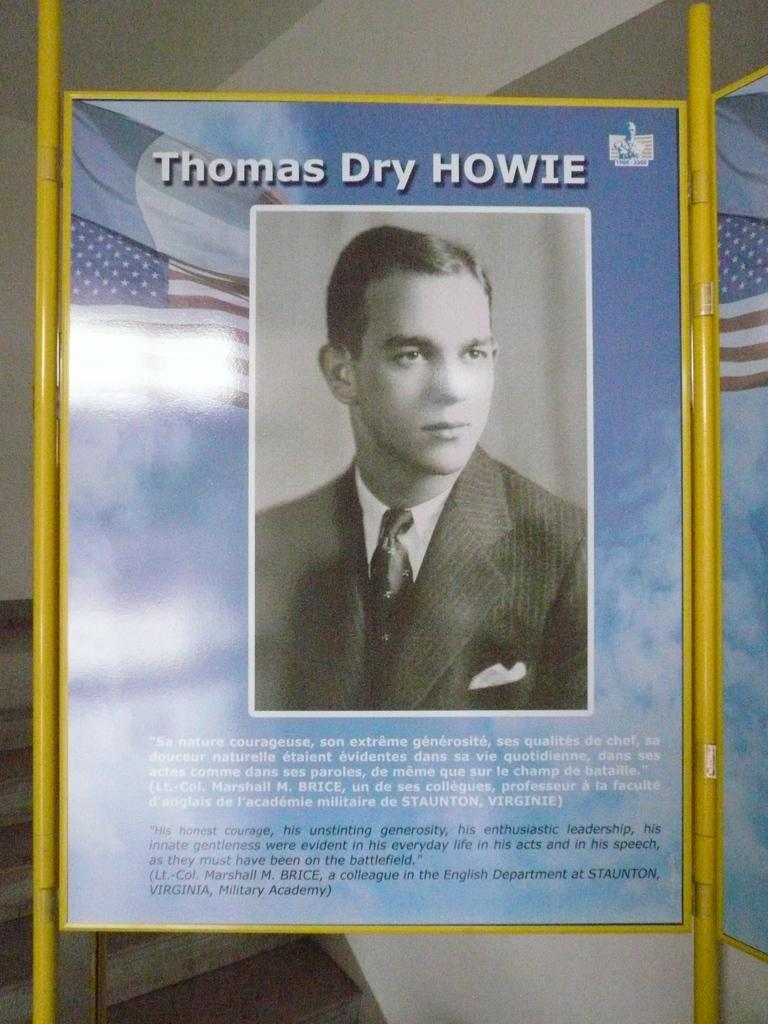<image>
Give a short and clear explanation of the subsequent image. A blurb about Thomas Dry Howie which praises him for his courage. 